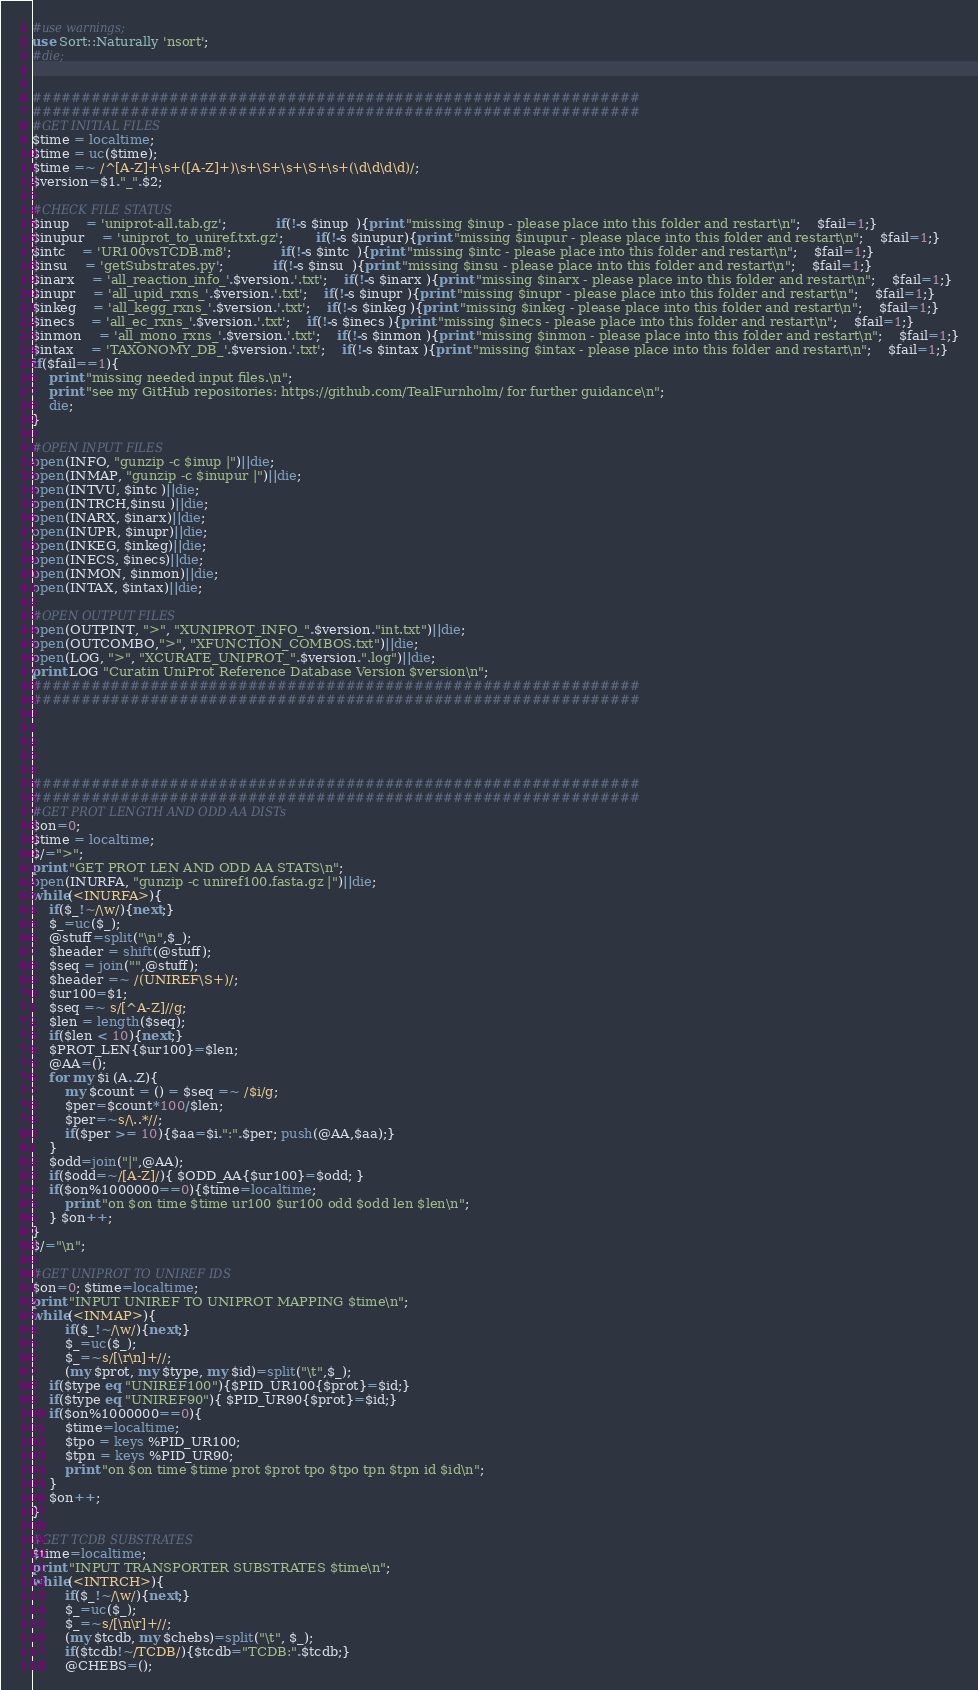Convert code to text. <code><loc_0><loc_0><loc_500><loc_500><_Perl_>#use warnings;
use Sort::Naturally 'nsort';
#die;


##############################################################
##############################################################
#GET INITIAL FILES
$time = localtime;
$time = uc($time);
$time =~ /^[A-Z]+\s+([A-Z]+)\s+\S+\s+\S+\s+(\d\d\d\d)/;
$version=$1."_".$2;

#CHECK FILE STATUS
$inup  	= 'uniprot-all.tab.gz';			if(!-s $inup  ){print "missing $inup - please place into this folder and restart\n";  	$fail=1;}
$inupur	= 'uniprot_to_uniref.txt.gz';		if(!-s $inupur){print "missing $inupur - please place into this folder and restart\n"; 	$fail=1;}
$intc	= 'UR100vsTCDB.m8';			if(!-s $intc  ){print "missing $intc - please place into this folder and restart\n";  	$fail=1;}
$insu	= 'getSubstrates.py';			if(!-s $insu  ){print "missing $insu - please place into this folder and restart\n";    $fail=1;}
$inarx 	= 'all_reaction_info_'.$version.'.txt';	if(!-s $inarx ){print "missing $inarx - please place into this folder and restart\n"; 	$fail=1;}
$inupr 	= 'all_upid_rxns_'.$version.'.txt';	if(!-s $inupr ){print "missing $inupr - please place into this folder and restart\n"; 	$fail=1;}
$inkeg 	= 'all_kegg_rxns_'.$version.'.txt';	if(!-s $inkeg ){print "missing $inkeg - please place into this folder and restart\n"; 	$fail=1;}
$inecs 	= 'all_ec_rxns_'.$version.'.txt';	if(!-s $inecs ){print "missing $inecs - please place into this folder and restart\n"; 	$fail=1;}
$inmon 	= 'all_mono_rxns_'.$version.'.txt';	if(!-s $inmon ){print "missing $inmon - please place into this folder and restart\n"; 	$fail=1;}
$intax 	= 'TAXONOMY_DB_'.$version.'.txt';	if(!-s $intax ){print "missing $intax - please place into this folder and restart\n"; 	$fail=1;}
if($fail==1){
	print "missing needed input files.\n"; 
	print "see my GitHub repositories: https://github.com/TealFurnholm/ for further guidance\n";
	die;
}

#OPEN INPUT FILES
open(INFO, "gunzip -c $inup |")||die;
open(INMAP, "gunzip -c $inupur |")||die;
open(INTVU, $intc )||die;
open(INTRCH,$insu )||die;
open(INARX, $inarx)||die;
open(INUPR, $inupr)||die;
open(INKEG, $inkeg)||die;
open(INECS, $inecs)||die;
open(INMON, $inmon)||die;
open(INTAX, $intax)||die;

#OPEN OUTPUT FILES
open(OUTPINT, ">", "XUNIPROT_INFO_".$version."int.txt")||die;
open(OUTCOMBO,">", "XFUNCTION_COMBOS.txt")||die;
open(LOG, ">", "XCURATE_UNIPROT_".$version.".log")||die;
print LOG "Curatin UniProt Reference Database Version $version\n";
##############################################################
##############################################################





##############################################################
##############################################################
#GET PROT LENGTH AND ODD AA DISTs
$on=0;
$time = localtime;
$/=">";
print "GET PROT LEN AND ODD AA STATS\n";
open(INURFA, "gunzip -c uniref100.fasta.gz |")||die;
while(<INURFA>){
	if($_!~/\w/){next;}
	$_=uc($_);
	@stuff=split("\n",$_);
	$header = shift(@stuff);
	$seq = join("",@stuff);
	$header =~ /(UNIREF\S+)/;
	$ur100=$1;
	$seq =~ s/[^A-Z]//g;
	$len = length($seq);
	if($len < 10){next;}
	$PROT_LEN{$ur100}=$len;
	@AA=();
	for my $i (A..Z){ 
		my $count = () = $seq =~ /$i/g; 
		$per=$count*100/$len;	
		$per=~s/\..*//;
		if($per >= 10){$aa=$i.":".$per; push(@AA,$aa);}
	}
	$odd=join("|",@AA);
	if($odd=~/[A-Z]/){ $ODD_AA{$ur100}=$odd; }
	if($on%1000000==0){$time=localtime; 
		print "on $on time $time ur100 $ur100 odd $odd len $len\n";
	} $on++;
}
$/="\n";

#GET UNIPROT TO UNIREF IDS
$on=0; $time=localtime;
print "INPUT UNIREF TO UNIPROT MAPPING $time\n";
while(<INMAP>){
        if($_!~/\w/){next;}
        $_=uc($_);
        $_=~s/[\r\n]+//;
        (my $prot, my $type, my $id)=split("\t",$_);
	if($type eq "UNIREF100"){$PID_UR100{$prot}=$id;}
	if($type eq "UNIREF90"){ $PID_UR90{$prot}=$id;}
	if($on%1000000==0){
		$time=localtime; 
		$tpo = keys %PID_UR100; 
		$tpn = keys %PID_UR90; 
		print "on $on time $time prot $prot tpo $tpo tpn $tpn id $id\n";
	}
	$on++; 
}

#GET TCDB SUBSTRATES
$time=localtime;
print "INPUT TRANSPORTER SUBSTRATES $time\n";
while(<INTRCH>){
        if($_!~/\w/){next;}
        $_=uc($_);
        $_=~s/[\n\r]+//;
        (my $tcdb, my $chebs)=split("\t", $_);
        if($tcdb!~/TCDB/){$tcdb="TCDB:".$tcdb;}
        @CHEBS=();</code> 